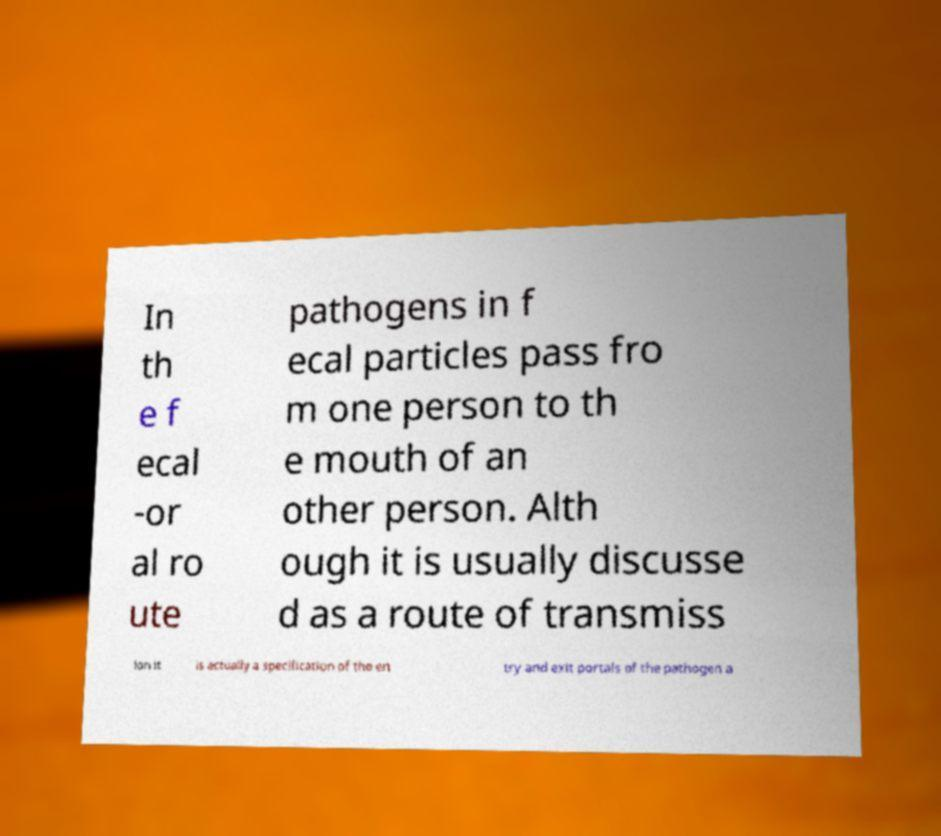What messages or text are displayed in this image? I need them in a readable, typed format. In th e f ecal -or al ro ute pathogens in f ecal particles pass fro m one person to th e mouth of an other person. Alth ough it is usually discusse d as a route of transmiss ion it is actually a specification of the en try and exit portals of the pathogen a 